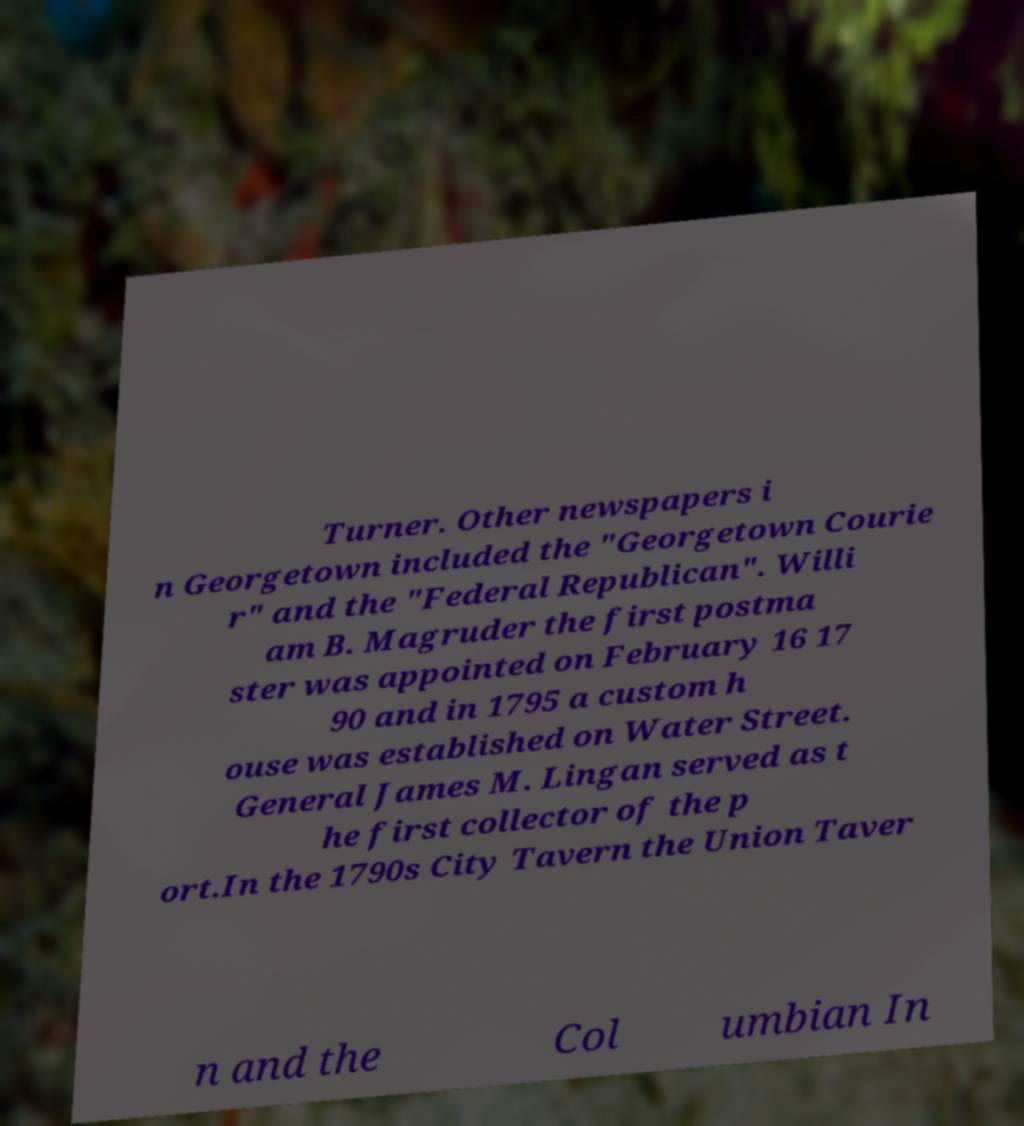Can you read and provide the text displayed in the image?This photo seems to have some interesting text. Can you extract and type it out for me? Turner. Other newspapers i n Georgetown included the "Georgetown Courie r" and the "Federal Republican". Willi am B. Magruder the first postma ster was appointed on February 16 17 90 and in 1795 a custom h ouse was established on Water Street. General James M. Lingan served as t he first collector of the p ort.In the 1790s City Tavern the Union Taver n and the Col umbian In 